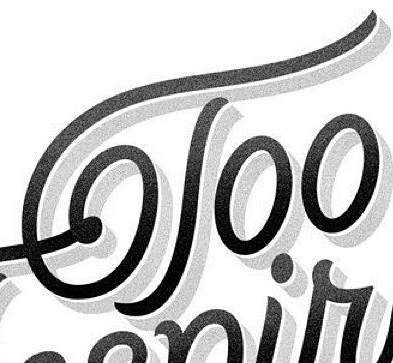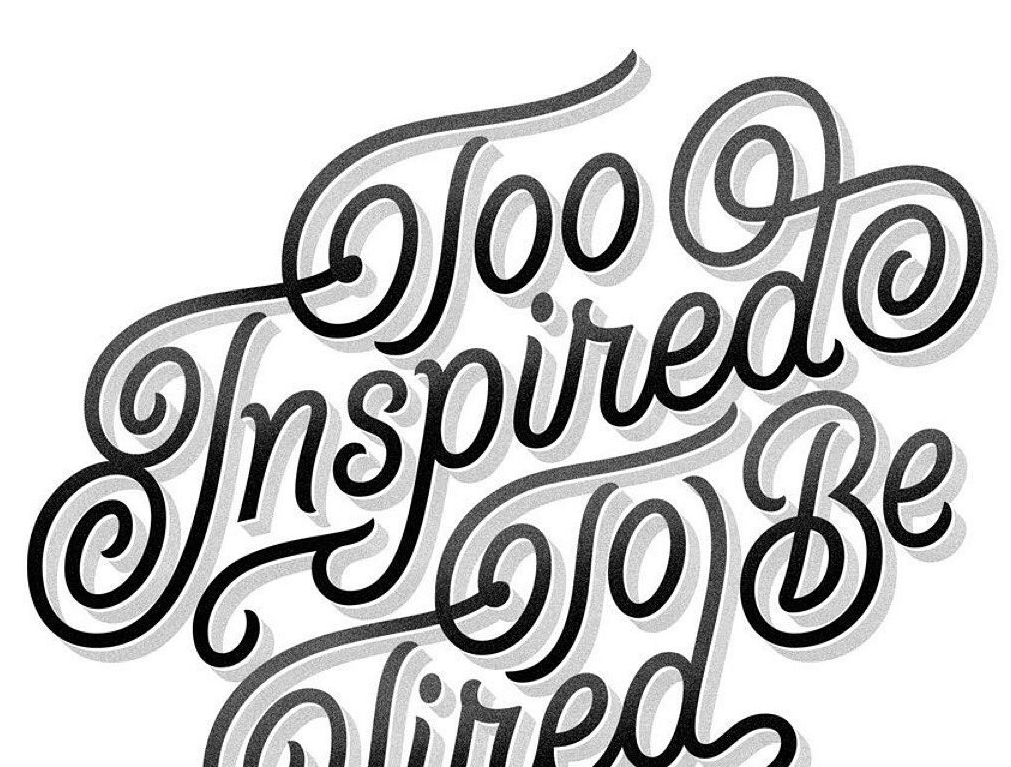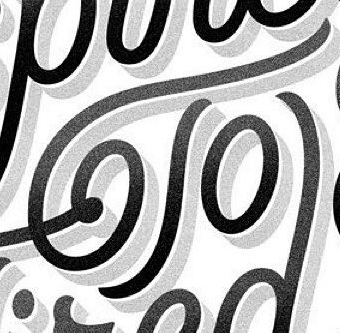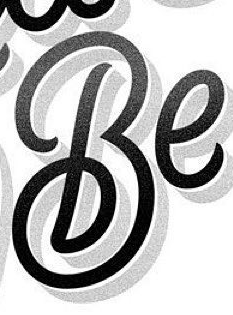Read the text content from these images in order, separated by a semicolon. Too; Inspired; To; Be 